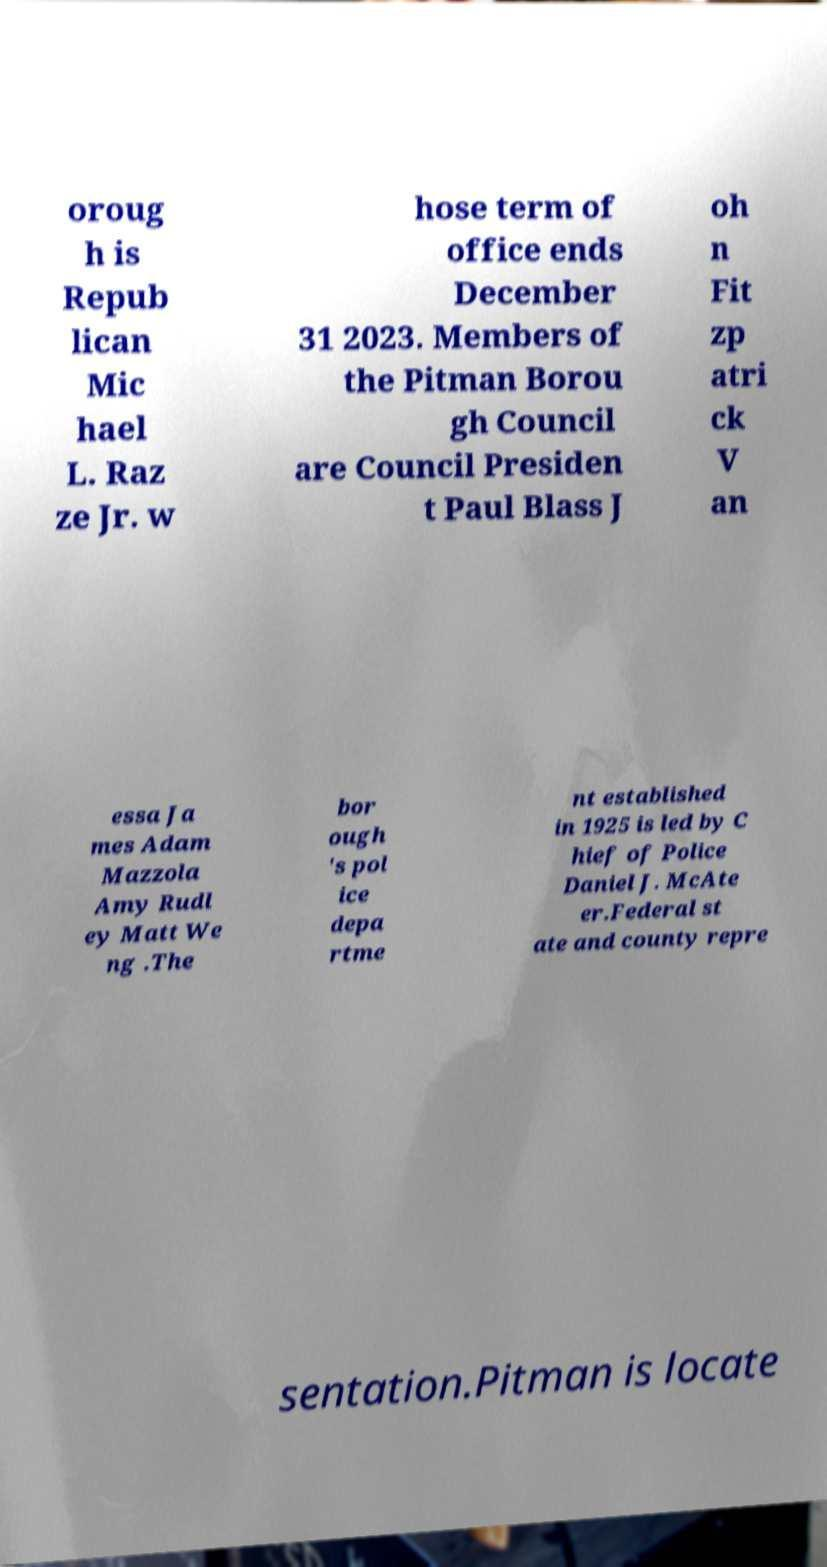Could you extract and type out the text from this image? oroug h is Repub lican Mic hael L. Raz ze Jr. w hose term of office ends December 31 2023. Members of the Pitman Borou gh Council are Council Presiden t Paul Blass J oh n Fit zp atri ck V an essa Ja mes Adam Mazzola Amy Rudl ey Matt We ng .The bor ough 's pol ice depa rtme nt established in 1925 is led by C hief of Police Daniel J. McAte er.Federal st ate and county repre sentation.Pitman is locate 